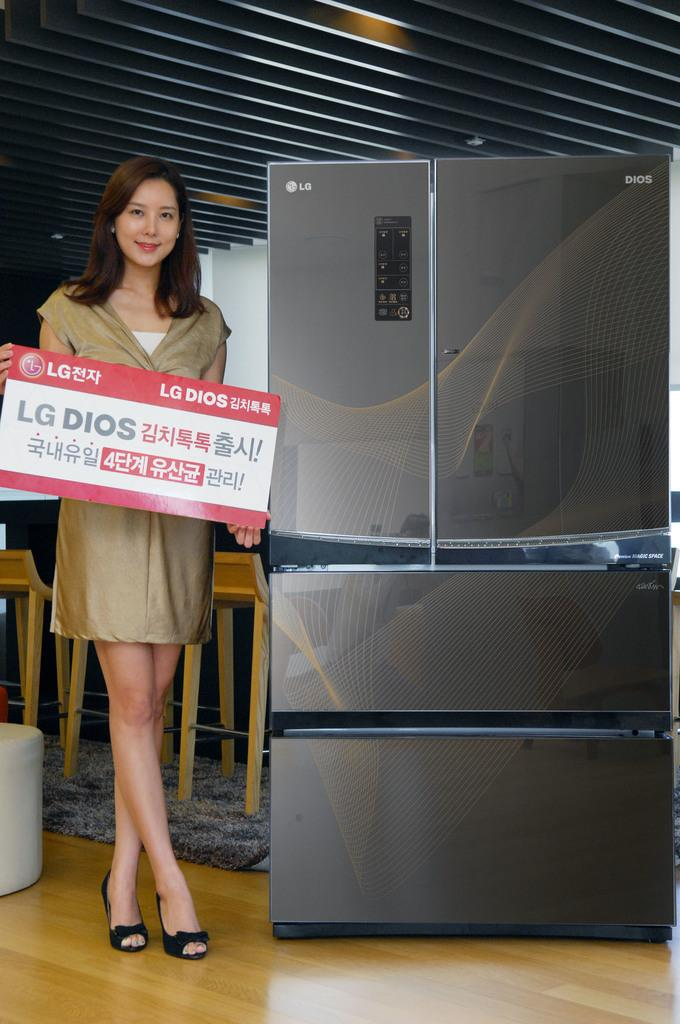<image>
Create a compact narrative representing the image presented. A lady standing next to a refrigerator is holding an LG sign 